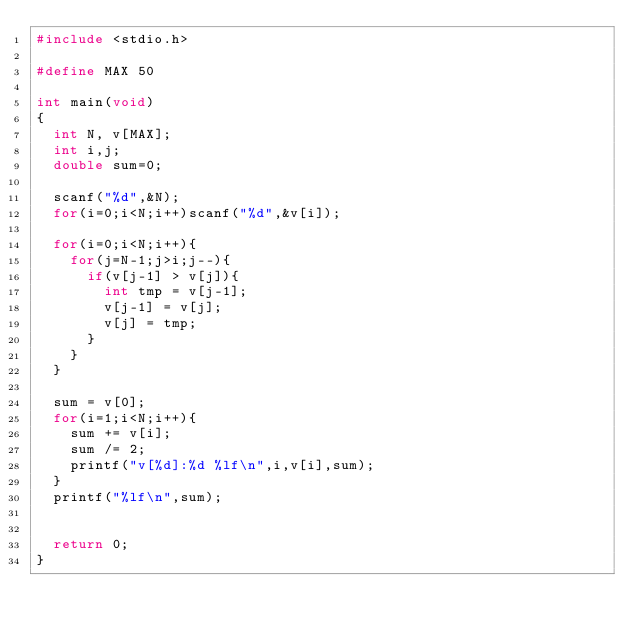Convert code to text. <code><loc_0><loc_0><loc_500><loc_500><_C_>#include <stdio.h>

#define MAX 50

int main(void)
{
  int N, v[MAX];
  int i,j;
  double sum=0;

  scanf("%d",&N);
  for(i=0;i<N;i++)scanf("%d",&v[i]);

  for(i=0;i<N;i++){
    for(j=N-1;j>i;j--){
      if(v[j-1] > v[j]){
        int tmp = v[j-1];
        v[j-1] = v[j];
        v[j] = tmp;
      }
    }
  }

  sum = v[0];
  for(i=1;i<N;i++){
    sum += v[i];
    sum /= 2;
    printf("v[%d]:%d %lf\n",i,v[i],sum);
  }
  printf("%lf\n",sum);


  return 0;
}
</code> 